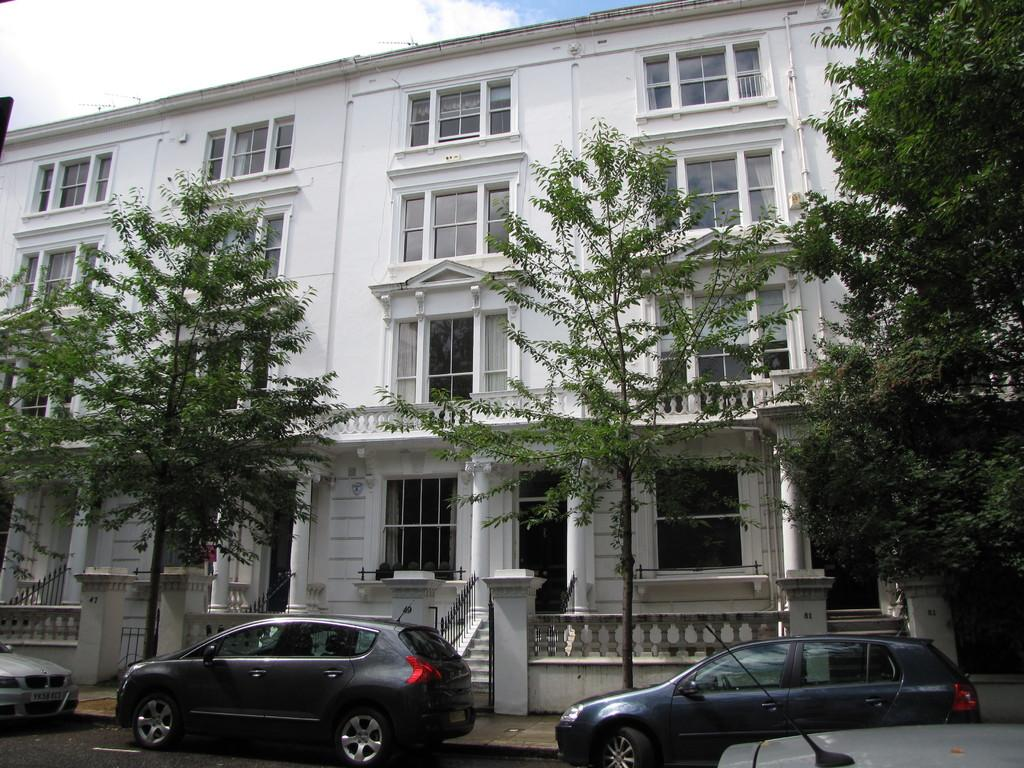What can be seen on the road in the image? There are vehicles on the road in the image. What type of natural elements are present in the image? There are trees in the image. What type of structure is visible in the image? There is a building in the image. What is visible in the background of the image? The sky is visible in the background of the image. Can you see a zebra crossing the road in the image? No, there is no zebra present in the image. Is there a volcano visible in the background of the image? No, there is no volcano present in the image. 